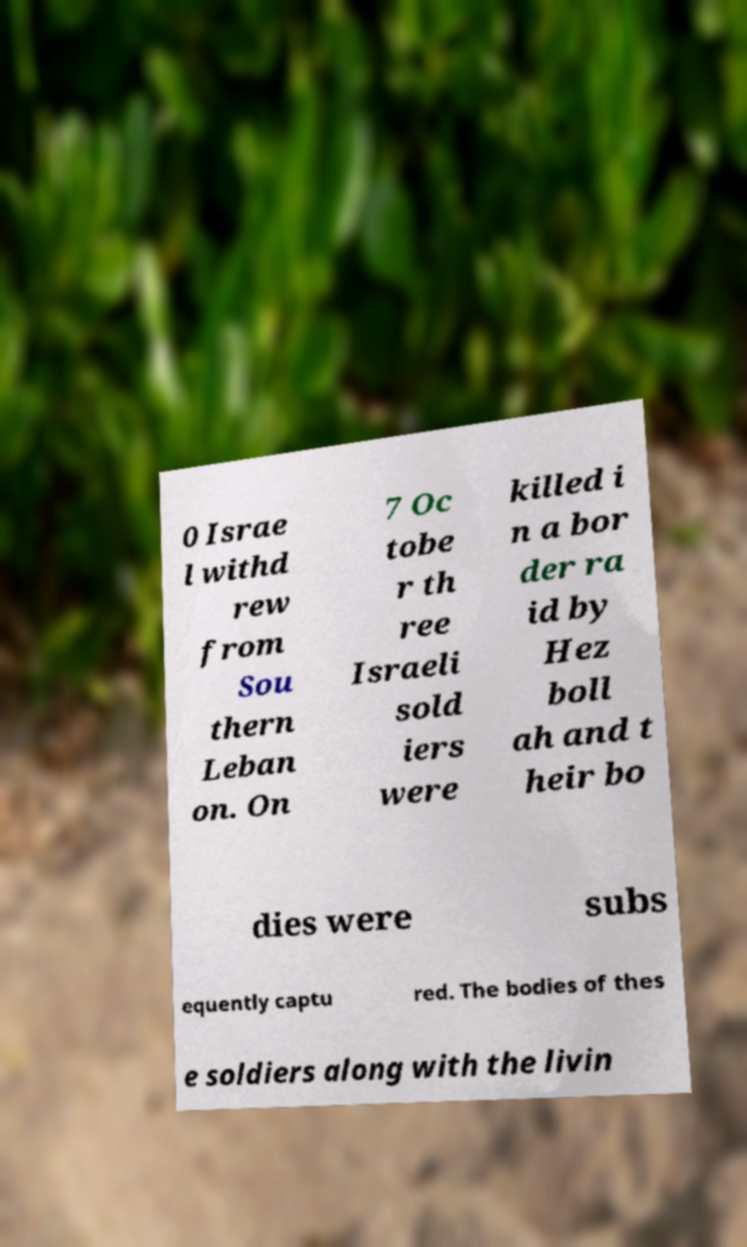Could you assist in decoding the text presented in this image and type it out clearly? 0 Israe l withd rew from Sou thern Leban on. On 7 Oc tobe r th ree Israeli sold iers were killed i n a bor der ra id by Hez boll ah and t heir bo dies were subs equently captu red. The bodies of thes e soldiers along with the livin 